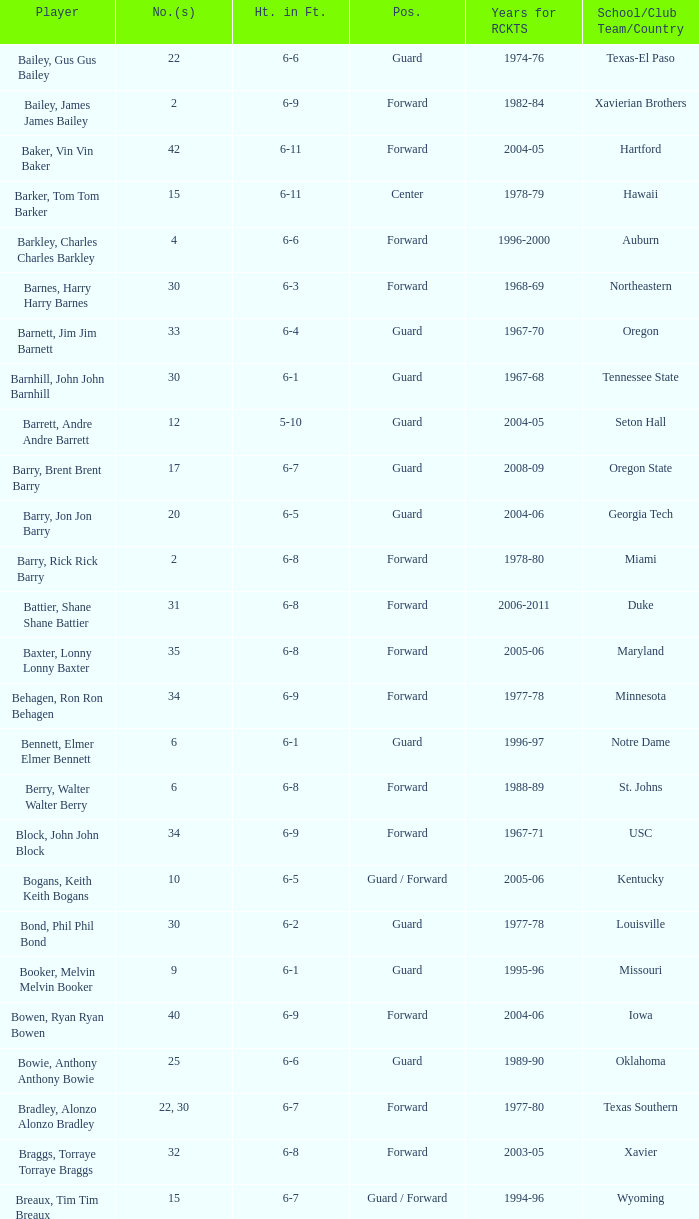What years did the player from LaSalle play for the Rockets? 1982-83. 